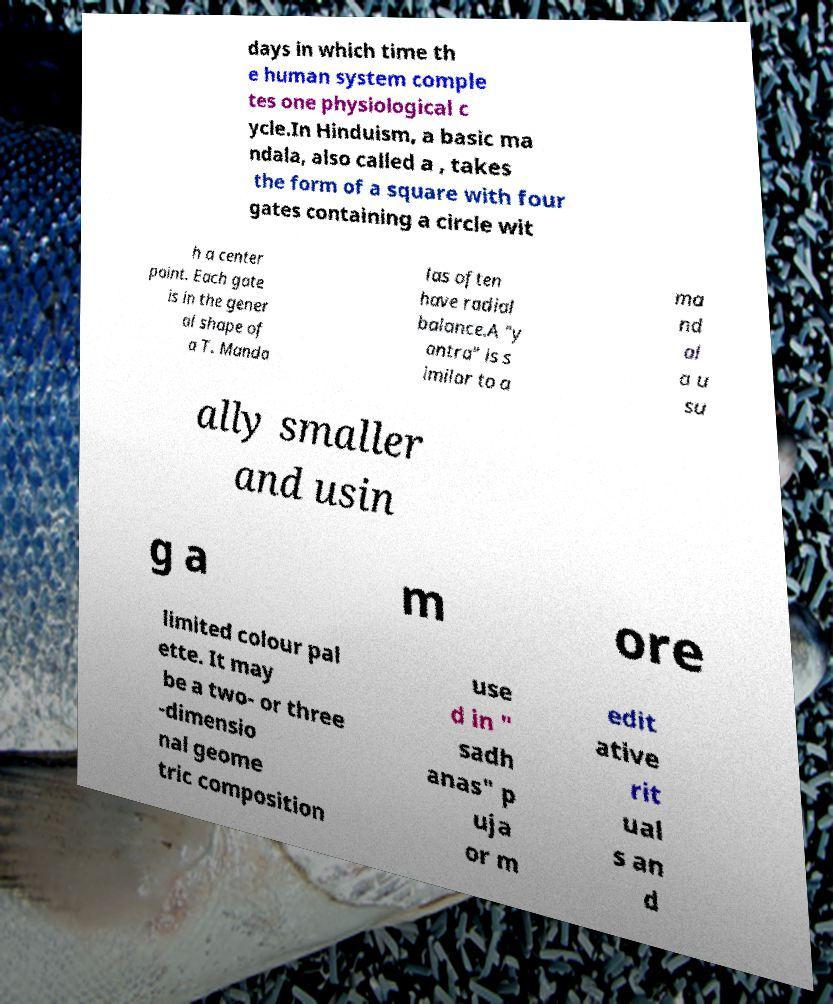What messages or text are displayed in this image? I need them in a readable, typed format. days in which time th e human system comple tes one physiological c ycle.In Hinduism, a basic ma ndala, also called a , takes the form of a square with four gates containing a circle wit h a center point. Each gate is in the gener al shape of a T. Manda las often have radial balance.A "y antra" is s imilar to a ma nd al a u su ally smaller and usin g a m ore limited colour pal ette. It may be a two- or three -dimensio nal geome tric composition use d in " sadh anas" p uja or m edit ative rit ual s an d 